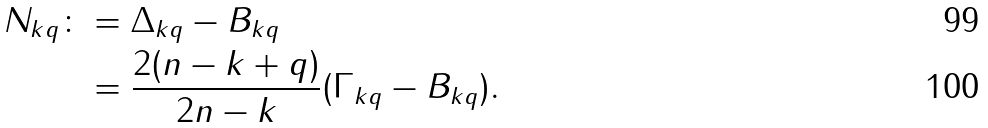Convert formula to latex. <formula><loc_0><loc_0><loc_500><loc_500>N _ { k q } \colon & = \Delta _ { k q } - B _ { k q } \\ & = \frac { 2 ( n - k + q ) } { 2 n - k } ( \Gamma _ { k q } - B _ { k q } ) .</formula> 